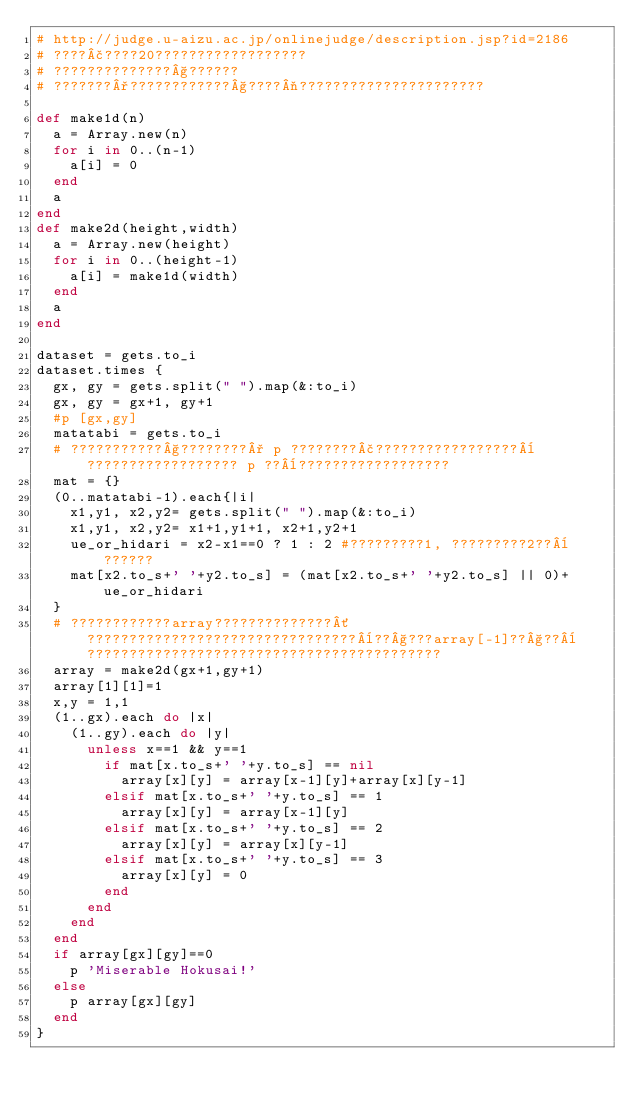<code> <loc_0><loc_0><loc_500><loc_500><_Ruby_># http://judge.u-aizu.ac.jp/onlinejudge/description.jsp?id=2186
# ????£????20??????????????????
# ??????????????§??????
# ???????°????????????§????¬??????????????????????

def make1d(n)
  a = Array.new(n)
  for i in 0..(n-1)
    a[i] = 0
  end
  a
end
def make2d(height,width)
  a = Array.new(height)
  for i in 0..(height-1)
    a[i] = make1d(width)
  end
  a
end

dataset = gets.to_i
dataset.times {
	gx, gy = gets.split(" ").map(&:to_i)
	gx, gy = gx+1, gy+1 
	#p [gx,gy]
	matatabi = gets.to_i
	# ???????????§????????° p ????????£?????????????????¨?????????????????? p ??¨??????????????????
	mat = {}
	(0..matatabi-1).each{|i|
		x1,y1, x2,y2= gets.split(" ").map(&:to_i)
		x1,y1, x2,y2= x1+1,y1+1, x2+1,y2+1
		ue_or_hidari = x2-x1==0 ? 1 : 2 #?????????1, ?????????2??¨??????
		mat[x2.to_s+' '+y2.to_s] = (mat[x2.to_s+' '+y2.to_s] || 0)+ue_or_hidari
	}
	# ????????????array??????????????´????????????????????????????????¨??§???array[-1]??§??¨??????????????????????????????????????????
	array = make2d(gx+1,gy+1)
	array[1][1]=1
	x,y = 1,1
	(1..gx).each do |x|
		(1..gy).each do |y|
			unless x==1 && y==1
				if mat[x.to_s+' '+y.to_s] == nil
					array[x][y] = array[x-1][y]+array[x][y-1]
				elsif mat[x.to_s+' '+y.to_s] == 1
					array[x][y] = array[x-1][y]
				elsif mat[x.to_s+' '+y.to_s] == 2
					array[x][y] = array[x][y-1]
				elsif mat[x.to_s+' '+y.to_s] == 3
					array[x][y] = 0
				end
			end
		end
	end
	if array[gx][gy]==0
		p 'Miserable Hokusai!'
	else
		p array[gx][gy]
	end
}</code> 